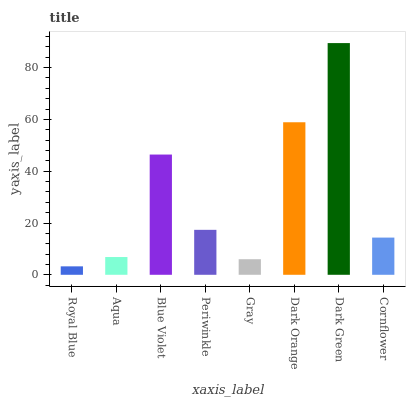Is Royal Blue the minimum?
Answer yes or no. Yes. Is Dark Green the maximum?
Answer yes or no. Yes. Is Aqua the minimum?
Answer yes or no. No. Is Aqua the maximum?
Answer yes or no. No. Is Aqua greater than Royal Blue?
Answer yes or no. Yes. Is Royal Blue less than Aqua?
Answer yes or no. Yes. Is Royal Blue greater than Aqua?
Answer yes or no. No. Is Aqua less than Royal Blue?
Answer yes or no. No. Is Periwinkle the high median?
Answer yes or no. Yes. Is Cornflower the low median?
Answer yes or no. Yes. Is Dark Orange the high median?
Answer yes or no. No. Is Aqua the low median?
Answer yes or no. No. 